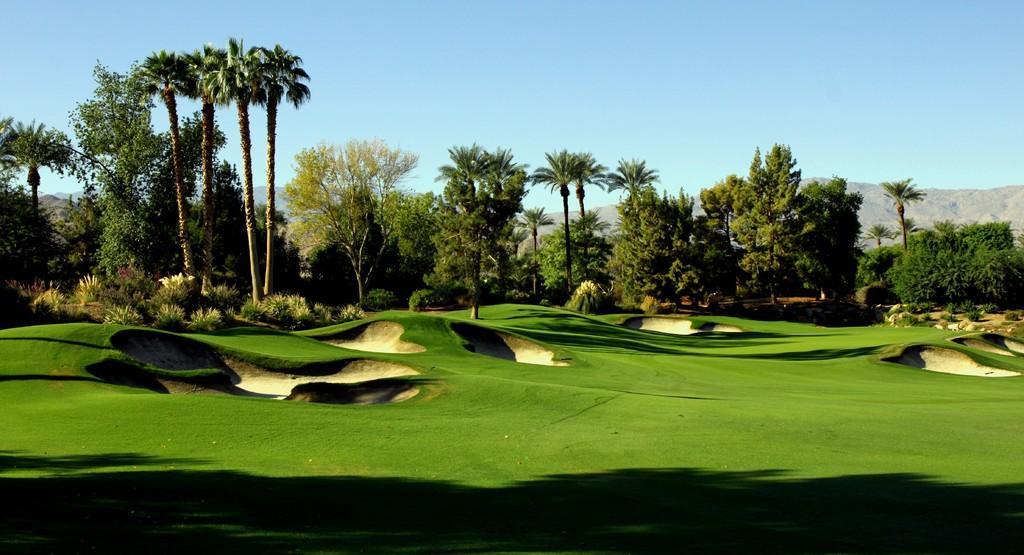How would you summarize this image in a sentence or two? In this image I can see grass, plants, trees, mountains and the sky. This image is taken may be in a park during a day. 